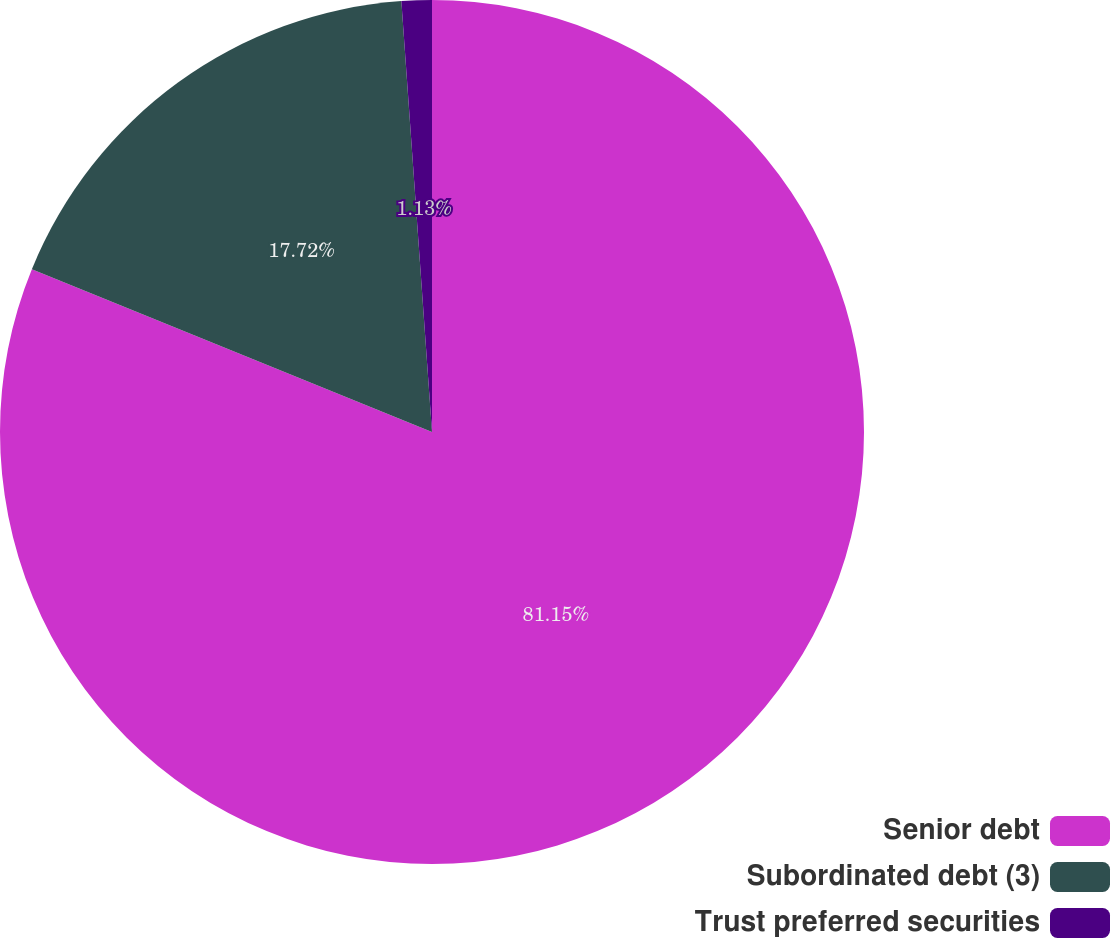<chart> <loc_0><loc_0><loc_500><loc_500><pie_chart><fcel>Senior debt<fcel>Subordinated debt (3)<fcel>Trust preferred securities<nl><fcel>81.16%<fcel>17.72%<fcel>1.13%<nl></chart> 